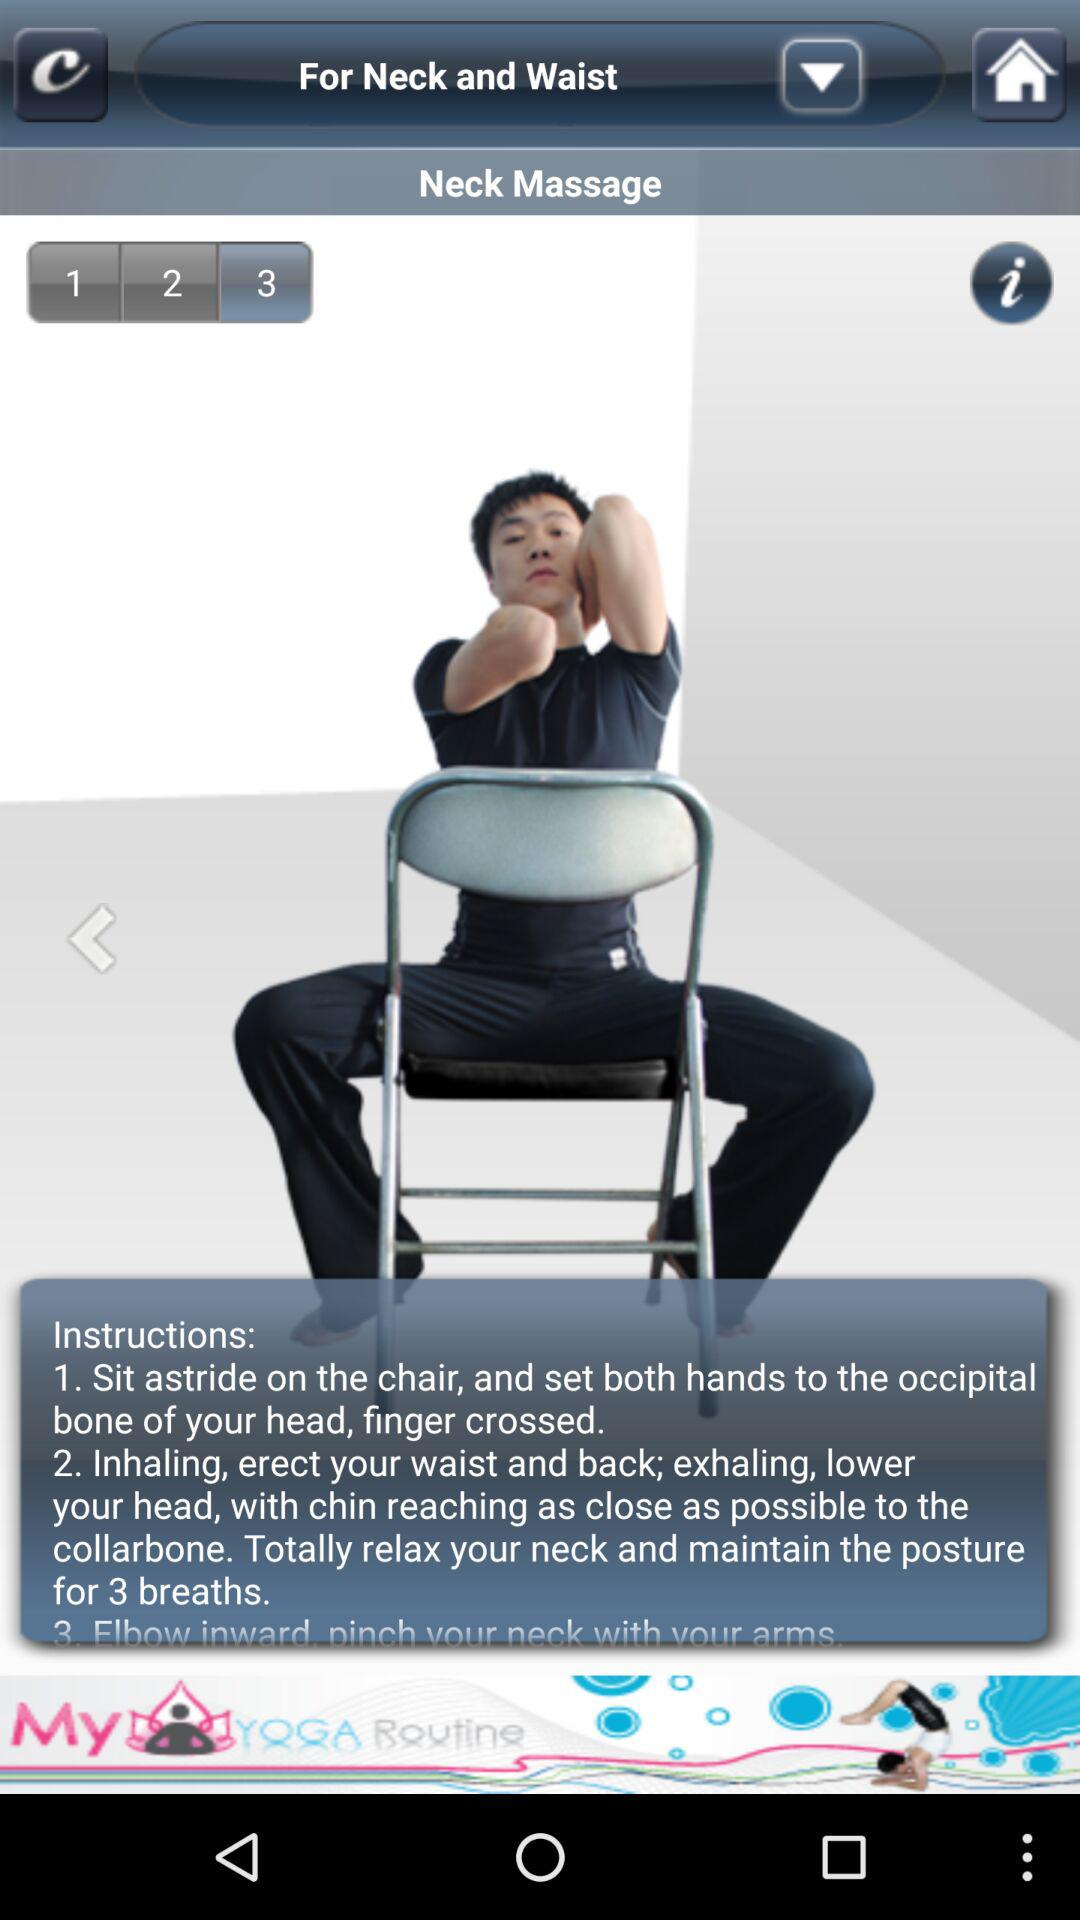What type of massage is this? It is neck massage. 